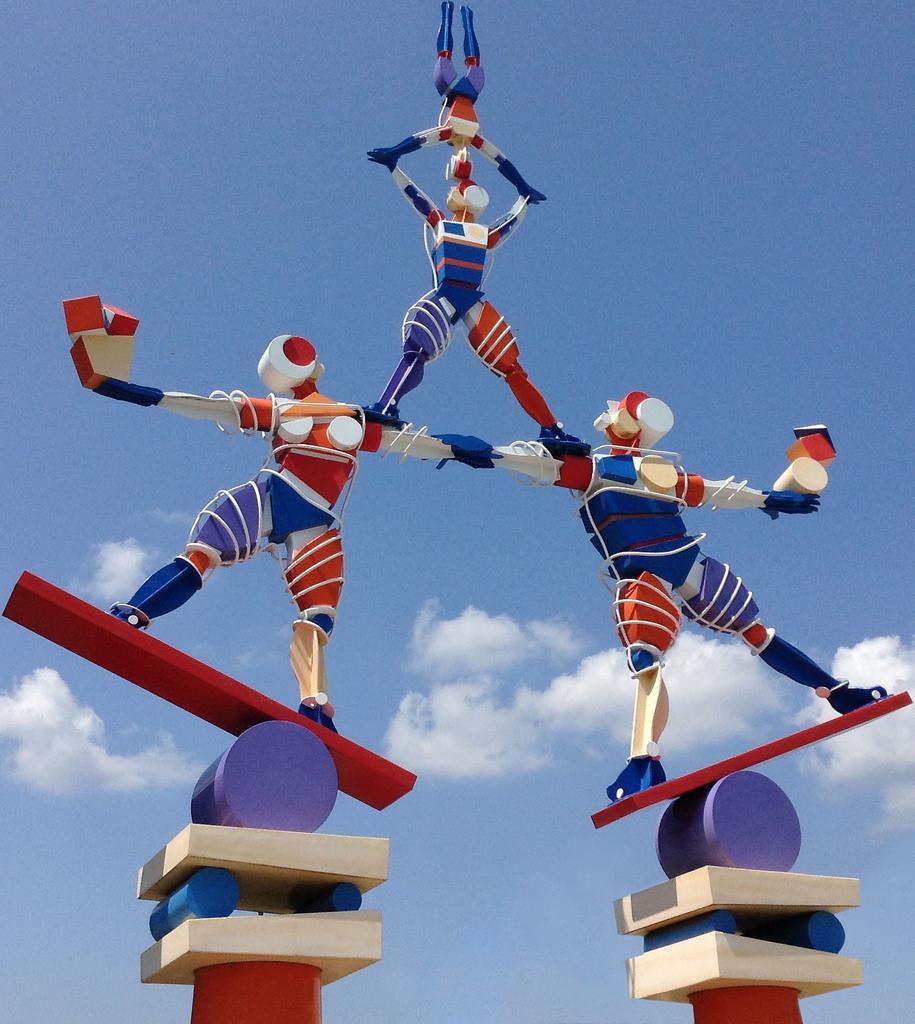How would you summarize this image in a sentence or two? There are some toy human beings on blocks. In the background there is sky with clouds. 